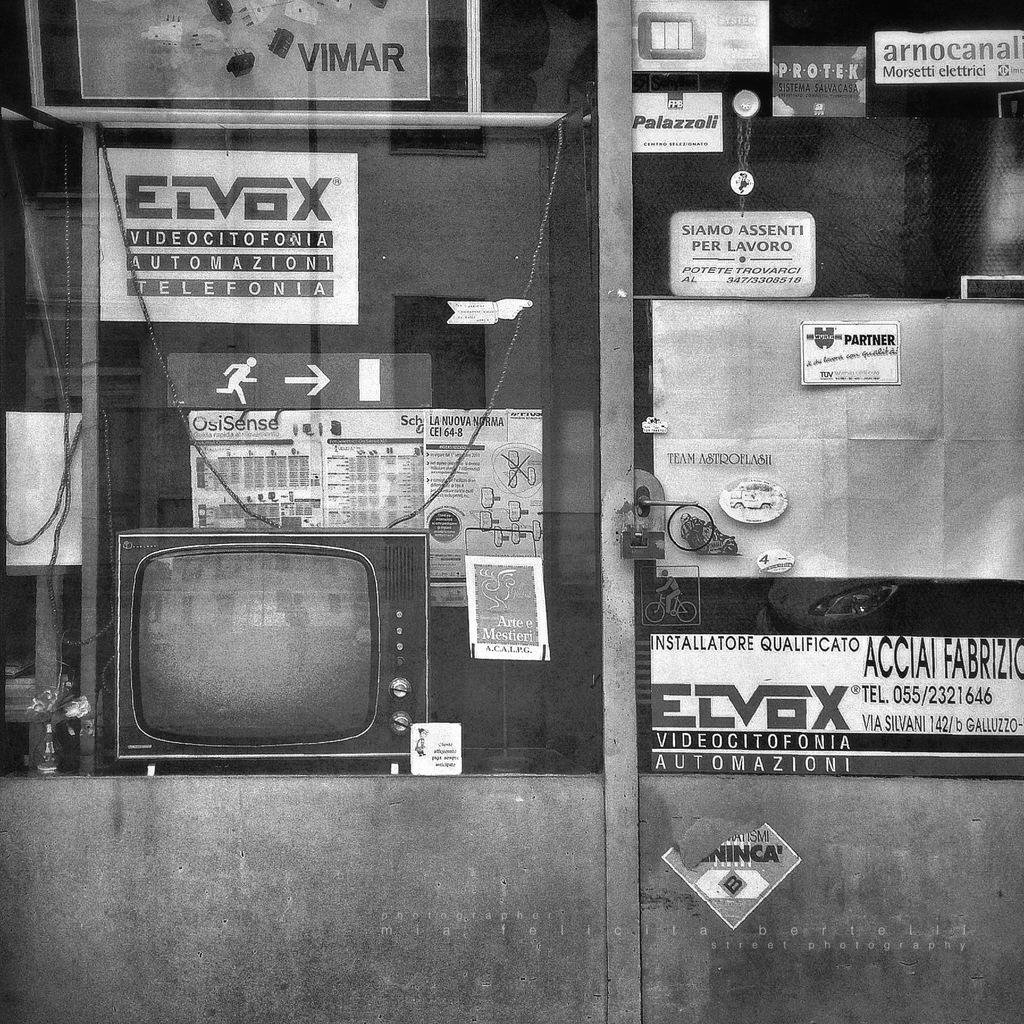Provide a one-sentence caption for the provided image. A grimy store window displays products from the Elvox company. 